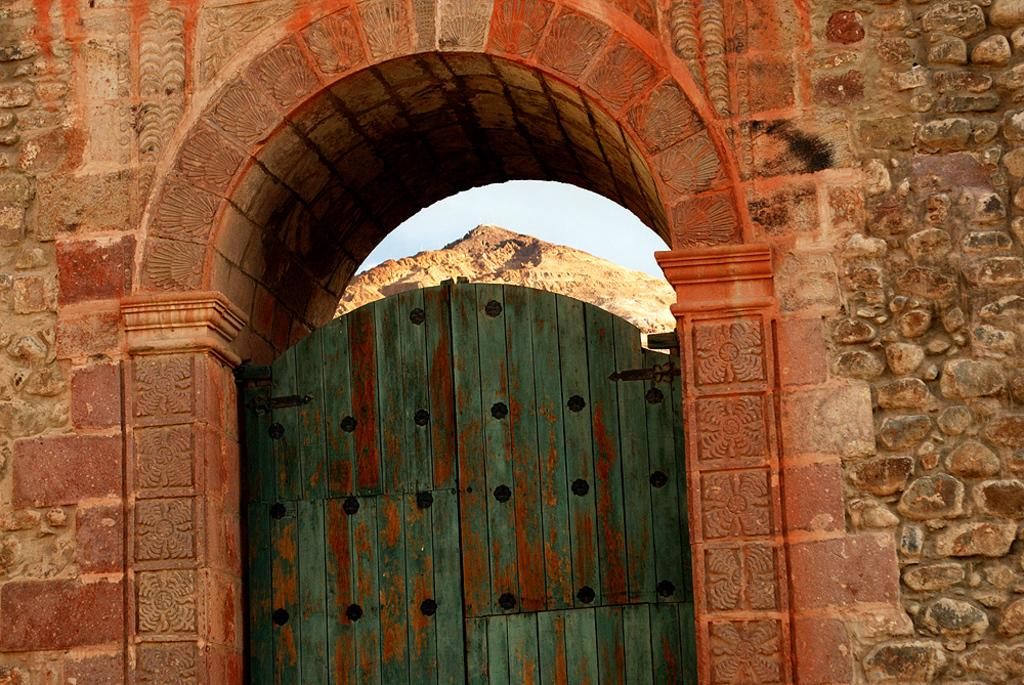What is the main structure in the image? There is an arc of a wall in the image. What is attached to the wall? There is a wooden door attached to the wall. What can be seen through the door? Inside the door, mountains are visible, as well as the sky. How many fingers can be seen on the parent's hand in the image? There are no people or hands visible in the image, so it is not possible to determine the number of fingers on a parent's hand. 